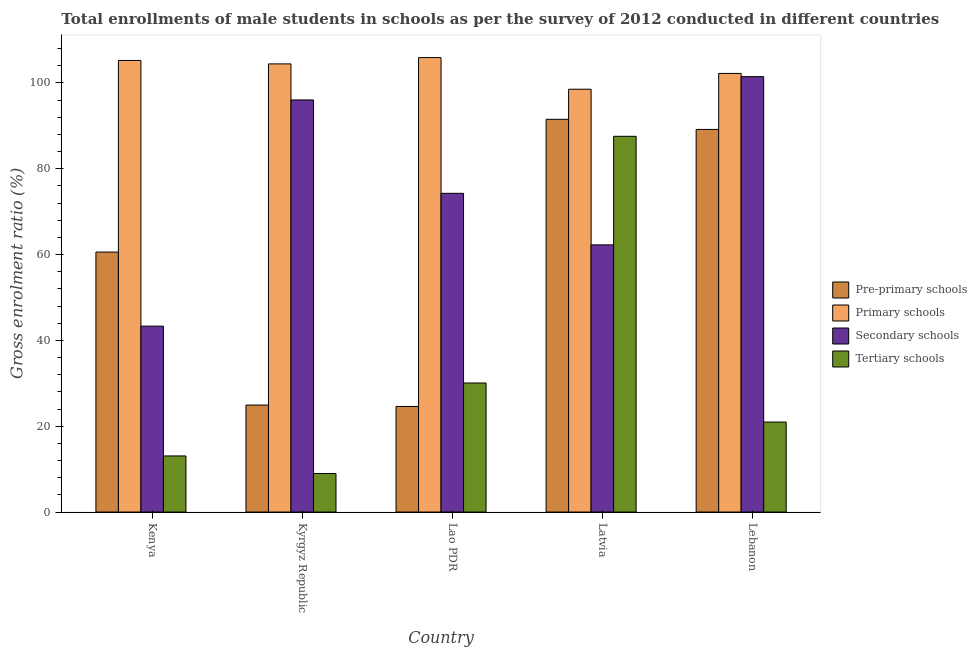How many different coloured bars are there?
Your response must be concise. 4. How many bars are there on the 2nd tick from the left?
Provide a short and direct response. 4. What is the label of the 2nd group of bars from the left?
Your answer should be very brief. Kyrgyz Republic. In how many cases, is the number of bars for a given country not equal to the number of legend labels?
Offer a terse response. 0. What is the gross enrolment ratio(male) in pre-primary schools in Lao PDR?
Keep it short and to the point. 24.6. Across all countries, what is the maximum gross enrolment ratio(male) in primary schools?
Offer a terse response. 105.9. Across all countries, what is the minimum gross enrolment ratio(male) in pre-primary schools?
Make the answer very short. 24.6. In which country was the gross enrolment ratio(male) in pre-primary schools maximum?
Your response must be concise. Latvia. In which country was the gross enrolment ratio(male) in primary schools minimum?
Keep it short and to the point. Latvia. What is the total gross enrolment ratio(male) in secondary schools in the graph?
Keep it short and to the point. 377.36. What is the difference between the gross enrolment ratio(male) in secondary schools in Kyrgyz Republic and that in Lao PDR?
Offer a very short reply. 21.76. What is the difference between the gross enrolment ratio(male) in secondary schools in Kenya and the gross enrolment ratio(male) in primary schools in Kyrgyz Republic?
Provide a succinct answer. -61.11. What is the average gross enrolment ratio(male) in tertiary schools per country?
Keep it short and to the point. 32.13. What is the difference between the gross enrolment ratio(male) in pre-primary schools and gross enrolment ratio(male) in tertiary schools in Kenya?
Make the answer very short. 47.51. What is the ratio of the gross enrolment ratio(male) in pre-primary schools in Kyrgyz Republic to that in Lebanon?
Offer a very short reply. 0.28. Is the difference between the gross enrolment ratio(male) in pre-primary schools in Kenya and Lebanon greater than the difference between the gross enrolment ratio(male) in primary schools in Kenya and Lebanon?
Your answer should be compact. No. What is the difference between the highest and the second highest gross enrolment ratio(male) in secondary schools?
Your response must be concise. 5.43. What is the difference between the highest and the lowest gross enrolment ratio(male) in secondary schools?
Give a very brief answer. 58.14. Is the sum of the gross enrolment ratio(male) in tertiary schools in Lao PDR and Latvia greater than the maximum gross enrolment ratio(male) in pre-primary schools across all countries?
Provide a short and direct response. Yes. Is it the case that in every country, the sum of the gross enrolment ratio(male) in pre-primary schools and gross enrolment ratio(male) in secondary schools is greater than the sum of gross enrolment ratio(male) in tertiary schools and gross enrolment ratio(male) in primary schools?
Your answer should be very brief. No. What does the 4th bar from the left in Lebanon represents?
Provide a succinct answer. Tertiary schools. What does the 2nd bar from the right in Kenya represents?
Offer a terse response. Secondary schools. Is it the case that in every country, the sum of the gross enrolment ratio(male) in pre-primary schools and gross enrolment ratio(male) in primary schools is greater than the gross enrolment ratio(male) in secondary schools?
Offer a very short reply. Yes. How many countries are there in the graph?
Give a very brief answer. 5. What is the difference between two consecutive major ticks on the Y-axis?
Your response must be concise. 20. Are the values on the major ticks of Y-axis written in scientific E-notation?
Your response must be concise. No. Where does the legend appear in the graph?
Give a very brief answer. Center right. How many legend labels are there?
Your answer should be very brief. 4. How are the legend labels stacked?
Offer a very short reply. Vertical. What is the title of the graph?
Give a very brief answer. Total enrollments of male students in schools as per the survey of 2012 conducted in different countries. Does "Secondary vocational education" appear as one of the legend labels in the graph?
Keep it short and to the point. No. What is the label or title of the X-axis?
Your answer should be compact. Country. What is the label or title of the Y-axis?
Your answer should be very brief. Gross enrolment ratio (%). What is the Gross enrolment ratio (%) in Pre-primary schools in Kenya?
Ensure brevity in your answer.  60.58. What is the Gross enrolment ratio (%) of Primary schools in Kenya?
Provide a short and direct response. 105.23. What is the Gross enrolment ratio (%) in Secondary schools in Kenya?
Your response must be concise. 43.32. What is the Gross enrolment ratio (%) in Tertiary schools in Kenya?
Offer a terse response. 13.07. What is the Gross enrolment ratio (%) in Pre-primary schools in Kyrgyz Republic?
Keep it short and to the point. 24.93. What is the Gross enrolment ratio (%) in Primary schools in Kyrgyz Republic?
Your response must be concise. 104.43. What is the Gross enrolment ratio (%) in Secondary schools in Kyrgyz Republic?
Keep it short and to the point. 96.03. What is the Gross enrolment ratio (%) of Tertiary schools in Kyrgyz Republic?
Your response must be concise. 8.98. What is the Gross enrolment ratio (%) in Pre-primary schools in Lao PDR?
Make the answer very short. 24.6. What is the Gross enrolment ratio (%) in Primary schools in Lao PDR?
Your answer should be very brief. 105.9. What is the Gross enrolment ratio (%) in Secondary schools in Lao PDR?
Offer a very short reply. 74.27. What is the Gross enrolment ratio (%) in Tertiary schools in Lao PDR?
Provide a succinct answer. 30.07. What is the Gross enrolment ratio (%) in Pre-primary schools in Latvia?
Offer a terse response. 91.52. What is the Gross enrolment ratio (%) in Primary schools in Latvia?
Give a very brief answer. 98.53. What is the Gross enrolment ratio (%) of Secondary schools in Latvia?
Ensure brevity in your answer.  62.26. What is the Gross enrolment ratio (%) of Tertiary schools in Latvia?
Ensure brevity in your answer.  87.56. What is the Gross enrolment ratio (%) of Pre-primary schools in Lebanon?
Your answer should be very brief. 89.16. What is the Gross enrolment ratio (%) of Primary schools in Lebanon?
Ensure brevity in your answer.  102.21. What is the Gross enrolment ratio (%) in Secondary schools in Lebanon?
Your response must be concise. 101.47. What is the Gross enrolment ratio (%) in Tertiary schools in Lebanon?
Keep it short and to the point. 20.97. Across all countries, what is the maximum Gross enrolment ratio (%) of Pre-primary schools?
Provide a short and direct response. 91.52. Across all countries, what is the maximum Gross enrolment ratio (%) in Primary schools?
Keep it short and to the point. 105.9. Across all countries, what is the maximum Gross enrolment ratio (%) in Secondary schools?
Give a very brief answer. 101.47. Across all countries, what is the maximum Gross enrolment ratio (%) in Tertiary schools?
Your answer should be compact. 87.56. Across all countries, what is the minimum Gross enrolment ratio (%) of Pre-primary schools?
Keep it short and to the point. 24.6. Across all countries, what is the minimum Gross enrolment ratio (%) of Primary schools?
Provide a short and direct response. 98.53. Across all countries, what is the minimum Gross enrolment ratio (%) of Secondary schools?
Give a very brief answer. 43.32. Across all countries, what is the minimum Gross enrolment ratio (%) of Tertiary schools?
Offer a terse response. 8.98. What is the total Gross enrolment ratio (%) of Pre-primary schools in the graph?
Keep it short and to the point. 290.79. What is the total Gross enrolment ratio (%) in Primary schools in the graph?
Your answer should be very brief. 516.31. What is the total Gross enrolment ratio (%) of Secondary schools in the graph?
Provide a short and direct response. 377.36. What is the total Gross enrolment ratio (%) of Tertiary schools in the graph?
Your answer should be very brief. 160.66. What is the difference between the Gross enrolment ratio (%) in Pre-primary schools in Kenya and that in Kyrgyz Republic?
Offer a very short reply. 35.65. What is the difference between the Gross enrolment ratio (%) of Primary schools in Kenya and that in Kyrgyz Republic?
Give a very brief answer. 0.8. What is the difference between the Gross enrolment ratio (%) of Secondary schools in Kenya and that in Kyrgyz Republic?
Provide a succinct answer. -52.71. What is the difference between the Gross enrolment ratio (%) in Tertiary schools in Kenya and that in Kyrgyz Republic?
Your response must be concise. 4.09. What is the difference between the Gross enrolment ratio (%) of Pre-primary schools in Kenya and that in Lao PDR?
Offer a very short reply. 35.98. What is the difference between the Gross enrolment ratio (%) of Primary schools in Kenya and that in Lao PDR?
Provide a short and direct response. -0.67. What is the difference between the Gross enrolment ratio (%) in Secondary schools in Kenya and that in Lao PDR?
Make the answer very short. -30.95. What is the difference between the Gross enrolment ratio (%) of Tertiary schools in Kenya and that in Lao PDR?
Give a very brief answer. -17. What is the difference between the Gross enrolment ratio (%) of Pre-primary schools in Kenya and that in Latvia?
Ensure brevity in your answer.  -30.94. What is the difference between the Gross enrolment ratio (%) of Primary schools in Kenya and that in Latvia?
Your answer should be compact. 6.7. What is the difference between the Gross enrolment ratio (%) of Secondary schools in Kenya and that in Latvia?
Ensure brevity in your answer.  -18.94. What is the difference between the Gross enrolment ratio (%) of Tertiary schools in Kenya and that in Latvia?
Offer a terse response. -74.49. What is the difference between the Gross enrolment ratio (%) of Pre-primary schools in Kenya and that in Lebanon?
Ensure brevity in your answer.  -28.58. What is the difference between the Gross enrolment ratio (%) of Primary schools in Kenya and that in Lebanon?
Offer a very short reply. 3.02. What is the difference between the Gross enrolment ratio (%) of Secondary schools in Kenya and that in Lebanon?
Keep it short and to the point. -58.14. What is the difference between the Gross enrolment ratio (%) in Tertiary schools in Kenya and that in Lebanon?
Ensure brevity in your answer.  -7.9. What is the difference between the Gross enrolment ratio (%) of Pre-primary schools in Kyrgyz Republic and that in Lao PDR?
Give a very brief answer. 0.33. What is the difference between the Gross enrolment ratio (%) of Primary schools in Kyrgyz Republic and that in Lao PDR?
Offer a very short reply. -1.47. What is the difference between the Gross enrolment ratio (%) of Secondary schools in Kyrgyz Republic and that in Lao PDR?
Make the answer very short. 21.76. What is the difference between the Gross enrolment ratio (%) of Tertiary schools in Kyrgyz Republic and that in Lao PDR?
Give a very brief answer. -21.09. What is the difference between the Gross enrolment ratio (%) in Pre-primary schools in Kyrgyz Republic and that in Latvia?
Your response must be concise. -66.59. What is the difference between the Gross enrolment ratio (%) in Primary schools in Kyrgyz Republic and that in Latvia?
Give a very brief answer. 5.9. What is the difference between the Gross enrolment ratio (%) of Secondary schools in Kyrgyz Republic and that in Latvia?
Offer a very short reply. 33.77. What is the difference between the Gross enrolment ratio (%) in Tertiary schools in Kyrgyz Republic and that in Latvia?
Keep it short and to the point. -78.58. What is the difference between the Gross enrolment ratio (%) in Pre-primary schools in Kyrgyz Republic and that in Lebanon?
Give a very brief answer. -64.23. What is the difference between the Gross enrolment ratio (%) of Primary schools in Kyrgyz Republic and that in Lebanon?
Your answer should be compact. 2.22. What is the difference between the Gross enrolment ratio (%) of Secondary schools in Kyrgyz Republic and that in Lebanon?
Offer a very short reply. -5.43. What is the difference between the Gross enrolment ratio (%) in Tertiary schools in Kyrgyz Republic and that in Lebanon?
Offer a terse response. -11.99. What is the difference between the Gross enrolment ratio (%) of Pre-primary schools in Lao PDR and that in Latvia?
Provide a succinct answer. -66.92. What is the difference between the Gross enrolment ratio (%) of Primary schools in Lao PDR and that in Latvia?
Keep it short and to the point. 7.37. What is the difference between the Gross enrolment ratio (%) in Secondary schools in Lao PDR and that in Latvia?
Your response must be concise. 12.01. What is the difference between the Gross enrolment ratio (%) in Tertiary schools in Lao PDR and that in Latvia?
Make the answer very short. -57.49. What is the difference between the Gross enrolment ratio (%) of Pre-primary schools in Lao PDR and that in Lebanon?
Provide a succinct answer. -64.56. What is the difference between the Gross enrolment ratio (%) in Primary schools in Lao PDR and that in Lebanon?
Provide a succinct answer. 3.69. What is the difference between the Gross enrolment ratio (%) in Secondary schools in Lao PDR and that in Lebanon?
Your answer should be compact. -27.19. What is the difference between the Gross enrolment ratio (%) of Tertiary schools in Lao PDR and that in Lebanon?
Keep it short and to the point. 9.1. What is the difference between the Gross enrolment ratio (%) in Pre-primary schools in Latvia and that in Lebanon?
Give a very brief answer. 2.36. What is the difference between the Gross enrolment ratio (%) of Primary schools in Latvia and that in Lebanon?
Offer a very short reply. -3.68. What is the difference between the Gross enrolment ratio (%) in Secondary schools in Latvia and that in Lebanon?
Give a very brief answer. -39.21. What is the difference between the Gross enrolment ratio (%) in Tertiary schools in Latvia and that in Lebanon?
Provide a succinct answer. 66.59. What is the difference between the Gross enrolment ratio (%) in Pre-primary schools in Kenya and the Gross enrolment ratio (%) in Primary schools in Kyrgyz Republic?
Your response must be concise. -43.85. What is the difference between the Gross enrolment ratio (%) of Pre-primary schools in Kenya and the Gross enrolment ratio (%) of Secondary schools in Kyrgyz Republic?
Ensure brevity in your answer.  -35.45. What is the difference between the Gross enrolment ratio (%) of Pre-primary schools in Kenya and the Gross enrolment ratio (%) of Tertiary schools in Kyrgyz Republic?
Your response must be concise. 51.6. What is the difference between the Gross enrolment ratio (%) in Primary schools in Kenya and the Gross enrolment ratio (%) in Secondary schools in Kyrgyz Republic?
Offer a very short reply. 9.2. What is the difference between the Gross enrolment ratio (%) of Primary schools in Kenya and the Gross enrolment ratio (%) of Tertiary schools in Kyrgyz Republic?
Give a very brief answer. 96.25. What is the difference between the Gross enrolment ratio (%) of Secondary schools in Kenya and the Gross enrolment ratio (%) of Tertiary schools in Kyrgyz Republic?
Your answer should be very brief. 34.34. What is the difference between the Gross enrolment ratio (%) in Pre-primary schools in Kenya and the Gross enrolment ratio (%) in Primary schools in Lao PDR?
Give a very brief answer. -45.32. What is the difference between the Gross enrolment ratio (%) in Pre-primary schools in Kenya and the Gross enrolment ratio (%) in Secondary schools in Lao PDR?
Keep it short and to the point. -13.69. What is the difference between the Gross enrolment ratio (%) in Pre-primary schools in Kenya and the Gross enrolment ratio (%) in Tertiary schools in Lao PDR?
Keep it short and to the point. 30.51. What is the difference between the Gross enrolment ratio (%) of Primary schools in Kenya and the Gross enrolment ratio (%) of Secondary schools in Lao PDR?
Offer a terse response. 30.96. What is the difference between the Gross enrolment ratio (%) of Primary schools in Kenya and the Gross enrolment ratio (%) of Tertiary schools in Lao PDR?
Your answer should be compact. 75.16. What is the difference between the Gross enrolment ratio (%) of Secondary schools in Kenya and the Gross enrolment ratio (%) of Tertiary schools in Lao PDR?
Offer a very short reply. 13.25. What is the difference between the Gross enrolment ratio (%) of Pre-primary schools in Kenya and the Gross enrolment ratio (%) of Primary schools in Latvia?
Offer a terse response. -37.95. What is the difference between the Gross enrolment ratio (%) of Pre-primary schools in Kenya and the Gross enrolment ratio (%) of Secondary schools in Latvia?
Keep it short and to the point. -1.68. What is the difference between the Gross enrolment ratio (%) in Pre-primary schools in Kenya and the Gross enrolment ratio (%) in Tertiary schools in Latvia?
Your answer should be compact. -26.98. What is the difference between the Gross enrolment ratio (%) in Primary schools in Kenya and the Gross enrolment ratio (%) in Secondary schools in Latvia?
Offer a very short reply. 42.97. What is the difference between the Gross enrolment ratio (%) of Primary schools in Kenya and the Gross enrolment ratio (%) of Tertiary schools in Latvia?
Your answer should be compact. 17.67. What is the difference between the Gross enrolment ratio (%) in Secondary schools in Kenya and the Gross enrolment ratio (%) in Tertiary schools in Latvia?
Provide a succinct answer. -44.24. What is the difference between the Gross enrolment ratio (%) in Pre-primary schools in Kenya and the Gross enrolment ratio (%) in Primary schools in Lebanon?
Your answer should be very brief. -41.63. What is the difference between the Gross enrolment ratio (%) in Pre-primary schools in Kenya and the Gross enrolment ratio (%) in Secondary schools in Lebanon?
Provide a short and direct response. -40.89. What is the difference between the Gross enrolment ratio (%) of Pre-primary schools in Kenya and the Gross enrolment ratio (%) of Tertiary schools in Lebanon?
Provide a succinct answer. 39.61. What is the difference between the Gross enrolment ratio (%) of Primary schools in Kenya and the Gross enrolment ratio (%) of Secondary schools in Lebanon?
Ensure brevity in your answer.  3.77. What is the difference between the Gross enrolment ratio (%) of Primary schools in Kenya and the Gross enrolment ratio (%) of Tertiary schools in Lebanon?
Give a very brief answer. 84.26. What is the difference between the Gross enrolment ratio (%) of Secondary schools in Kenya and the Gross enrolment ratio (%) of Tertiary schools in Lebanon?
Offer a very short reply. 22.35. What is the difference between the Gross enrolment ratio (%) in Pre-primary schools in Kyrgyz Republic and the Gross enrolment ratio (%) in Primary schools in Lao PDR?
Your answer should be very brief. -80.97. What is the difference between the Gross enrolment ratio (%) in Pre-primary schools in Kyrgyz Republic and the Gross enrolment ratio (%) in Secondary schools in Lao PDR?
Give a very brief answer. -49.34. What is the difference between the Gross enrolment ratio (%) in Pre-primary schools in Kyrgyz Republic and the Gross enrolment ratio (%) in Tertiary schools in Lao PDR?
Keep it short and to the point. -5.14. What is the difference between the Gross enrolment ratio (%) of Primary schools in Kyrgyz Republic and the Gross enrolment ratio (%) of Secondary schools in Lao PDR?
Offer a very short reply. 30.16. What is the difference between the Gross enrolment ratio (%) of Primary schools in Kyrgyz Republic and the Gross enrolment ratio (%) of Tertiary schools in Lao PDR?
Offer a terse response. 74.36. What is the difference between the Gross enrolment ratio (%) in Secondary schools in Kyrgyz Republic and the Gross enrolment ratio (%) in Tertiary schools in Lao PDR?
Your response must be concise. 65.96. What is the difference between the Gross enrolment ratio (%) in Pre-primary schools in Kyrgyz Republic and the Gross enrolment ratio (%) in Primary schools in Latvia?
Give a very brief answer. -73.6. What is the difference between the Gross enrolment ratio (%) of Pre-primary schools in Kyrgyz Republic and the Gross enrolment ratio (%) of Secondary schools in Latvia?
Make the answer very short. -37.33. What is the difference between the Gross enrolment ratio (%) in Pre-primary schools in Kyrgyz Republic and the Gross enrolment ratio (%) in Tertiary schools in Latvia?
Provide a short and direct response. -62.63. What is the difference between the Gross enrolment ratio (%) in Primary schools in Kyrgyz Republic and the Gross enrolment ratio (%) in Secondary schools in Latvia?
Ensure brevity in your answer.  42.17. What is the difference between the Gross enrolment ratio (%) of Primary schools in Kyrgyz Republic and the Gross enrolment ratio (%) of Tertiary schools in Latvia?
Keep it short and to the point. 16.87. What is the difference between the Gross enrolment ratio (%) in Secondary schools in Kyrgyz Republic and the Gross enrolment ratio (%) in Tertiary schools in Latvia?
Provide a short and direct response. 8.47. What is the difference between the Gross enrolment ratio (%) in Pre-primary schools in Kyrgyz Republic and the Gross enrolment ratio (%) in Primary schools in Lebanon?
Your answer should be very brief. -77.28. What is the difference between the Gross enrolment ratio (%) of Pre-primary schools in Kyrgyz Republic and the Gross enrolment ratio (%) of Secondary schools in Lebanon?
Keep it short and to the point. -76.53. What is the difference between the Gross enrolment ratio (%) of Pre-primary schools in Kyrgyz Republic and the Gross enrolment ratio (%) of Tertiary schools in Lebanon?
Provide a short and direct response. 3.96. What is the difference between the Gross enrolment ratio (%) of Primary schools in Kyrgyz Republic and the Gross enrolment ratio (%) of Secondary schools in Lebanon?
Make the answer very short. 2.97. What is the difference between the Gross enrolment ratio (%) of Primary schools in Kyrgyz Republic and the Gross enrolment ratio (%) of Tertiary schools in Lebanon?
Provide a succinct answer. 83.46. What is the difference between the Gross enrolment ratio (%) in Secondary schools in Kyrgyz Republic and the Gross enrolment ratio (%) in Tertiary schools in Lebanon?
Make the answer very short. 75.06. What is the difference between the Gross enrolment ratio (%) in Pre-primary schools in Lao PDR and the Gross enrolment ratio (%) in Primary schools in Latvia?
Ensure brevity in your answer.  -73.93. What is the difference between the Gross enrolment ratio (%) of Pre-primary schools in Lao PDR and the Gross enrolment ratio (%) of Secondary schools in Latvia?
Keep it short and to the point. -37.66. What is the difference between the Gross enrolment ratio (%) in Pre-primary schools in Lao PDR and the Gross enrolment ratio (%) in Tertiary schools in Latvia?
Your response must be concise. -62.96. What is the difference between the Gross enrolment ratio (%) of Primary schools in Lao PDR and the Gross enrolment ratio (%) of Secondary schools in Latvia?
Provide a short and direct response. 43.64. What is the difference between the Gross enrolment ratio (%) in Primary schools in Lao PDR and the Gross enrolment ratio (%) in Tertiary schools in Latvia?
Your answer should be compact. 18.34. What is the difference between the Gross enrolment ratio (%) in Secondary schools in Lao PDR and the Gross enrolment ratio (%) in Tertiary schools in Latvia?
Your answer should be very brief. -13.29. What is the difference between the Gross enrolment ratio (%) of Pre-primary schools in Lao PDR and the Gross enrolment ratio (%) of Primary schools in Lebanon?
Make the answer very short. -77.61. What is the difference between the Gross enrolment ratio (%) in Pre-primary schools in Lao PDR and the Gross enrolment ratio (%) in Secondary schools in Lebanon?
Your answer should be compact. -76.86. What is the difference between the Gross enrolment ratio (%) in Pre-primary schools in Lao PDR and the Gross enrolment ratio (%) in Tertiary schools in Lebanon?
Make the answer very short. 3.63. What is the difference between the Gross enrolment ratio (%) in Primary schools in Lao PDR and the Gross enrolment ratio (%) in Secondary schools in Lebanon?
Your answer should be very brief. 4.44. What is the difference between the Gross enrolment ratio (%) of Primary schools in Lao PDR and the Gross enrolment ratio (%) of Tertiary schools in Lebanon?
Make the answer very short. 84.93. What is the difference between the Gross enrolment ratio (%) in Secondary schools in Lao PDR and the Gross enrolment ratio (%) in Tertiary schools in Lebanon?
Provide a succinct answer. 53.3. What is the difference between the Gross enrolment ratio (%) in Pre-primary schools in Latvia and the Gross enrolment ratio (%) in Primary schools in Lebanon?
Provide a short and direct response. -10.69. What is the difference between the Gross enrolment ratio (%) in Pre-primary schools in Latvia and the Gross enrolment ratio (%) in Secondary schools in Lebanon?
Give a very brief answer. -9.95. What is the difference between the Gross enrolment ratio (%) in Pre-primary schools in Latvia and the Gross enrolment ratio (%) in Tertiary schools in Lebanon?
Ensure brevity in your answer.  70.55. What is the difference between the Gross enrolment ratio (%) in Primary schools in Latvia and the Gross enrolment ratio (%) in Secondary schools in Lebanon?
Provide a succinct answer. -2.94. What is the difference between the Gross enrolment ratio (%) in Primary schools in Latvia and the Gross enrolment ratio (%) in Tertiary schools in Lebanon?
Your response must be concise. 77.56. What is the difference between the Gross enrolment ratio (%) of Secondary schools in Latvia and the Gross enrolment ratio (%) of Tertiary schools in Lebanon?
Make the answer very short. 41.29. What is the average Gross enrolment ratio (%) of Pre-primary schools per country?
Your answer should be compact. 58.16. What is the average Gross enrolment ratio (%) in Primary schools per country?
Provide a short and direct response. 103.26. What is the average Gross enrolment ratio (%) in Secondary schools per country?
Offer a very short reply. 75.47. What is the average Gross enrolment ratio (%) of Tertiary schools per country?
Provide a succinct answer. 32.13. What is the difference between the Gross enrolment ratio (%) in Pre-primary schools and Gross enrolment ratio (%) in Primary schools in Kenya?
Your answer should be very brief. -44.65. What is the difference between the Gross enrolment ratio (%) in Pre-primary schools and Gross enrolment ratio (%) in Secondary schools in Kenya?
Offer a very short reply. 17.26. What is the difference between the Gross enrolment ratio (%) in Pre-primary schools and Gross enrolment ratio (%) in Tertiary schools in Kenya?
Your response must be concise. 47.51. What is the difference between the Gross enrolment ratio (%) of Primary schools and Gross enrolment ratio (%) of Secondary schools in Kenya?
Offer a terse response. 61.91. What is the difference between the Gross enrolment ratio (%) of Primary schools and Gross enrolment ratio (%) of Tertiary schools in Kenya?
Make the answer very short. 92.16. What is the difference between the Gross enrolment ratio (%) in Secondary schools and Gross enrolment ratio (%) in Tertiary schools in Kenya?
Your response must be concise. 30.25. What is the difference between the Gross enrolment ratio (%) of Pre-primary schools and Gross enrolment ratio (%) of Primary schools in Kyrgyz Republic?
Provide a short and direct response. -79.5. What is the difference between the Gross enrolment ratio (%) in Pre-primary schools and Gross enrolment ratio (%) in Secondary schools in Kyrgyz Republic?
Make the answer very short. -71.1. What is the difference between the Gross enrolment ratio (%) in Pre-primary schools and Gross enrolment ratio (%) in Tertiary schools in Kyrgyz Republic?
Ensure brevity in your answer.  15.95. What is the difference between the Gross enrolment ratio (%) of Primary schools and Gross enrolment ratio (%) of Secondary schools in Kyrgyz Republic?
Provide a short and direct response. 8.4. What is the difference between the Gross enrolment ratio (%) in Primary schools and Gross enrolment ratio (%) in Tertiary schools in Kyrgyz Republic?
Your answer should be very brief. 95.45. What is the difference between the Gross enrolment ratio (%) of Secondary schools and Gross enrolment ratio (%) of Tertiary schools in Kyrgyz Republic?
Provide a succinct answer. 87.05. What is the difference between the Gross enrolment ratio (%) in Pre-primary schools and Gross enrolment ratio (%) in Primary schools in Lao PDR?
Give a very brief answer. -81.3. What is the difference between the Gross enrolment ratio (%) of Pre-primary schools and Gross enrolment ratio (%) of Secondary schools in Lao PDR?
Provide a short and direct response. -49.67. What is the difference between the Gross enrolment ratio (%) of Pre-primary schools and Gross enrolment ratio (%) of Tertiary schools in Lao PDR?
Give a very brief answer. -5.47. What is the difference between the Gross enrolment ratio (%) in Primary schools and Gross enrolment ratio (%) in Secondary schools in Lao PDR?
Your response must be concise. 31.63. What is the difference between the Gross enrolment ratio (%) in Primary schools and Gross enrolment ratio (%) in Tertiary schools in Lao PDR?
Ensure brevity in your answer.  75.83. What is the difference between the Gross enrolment ratio (%) in Secondary schools and Gross enrolment ratio (%) in Tertiary schools in Lao PDR?
Provide a short and direct response. 44.2. What is the difference between the Gross enrolment ratio (%) of Pre-primary schools and Gross enrolment ratio (%) of Primary schools in Latvia?
Ensure brevity in your answer.  -7.01. What is the difference between the Gross enrolment ratio (%) in Pre-primary schools and Gross enrolment ratio (%) in Secondary schools in Latvia?
Give a very brief answer. 29.26. What is the difference between the Gross enrolment ratio (%) of Pre-primary schools and Gross enrolment ratio (%) of Tertiary schools in Latvia?
Keep it short and to the point. 3.96. What is the difference between the Gross enrolment ratio (%) of Primary schools and Gross enrolment ratio (%) of Secondary schools in Latvia?
Provide a short and direct response. 36.27. What is the difference between the Gross enrolment ratio (%) in Primary schools and Gross enrolment ratio (%) in Tertiary schools in Latvia?
Ensure brevity in your answer.  10.97. What is the difference between the Gross enrolment ratio (%) in Secondary schools and Gross enrolment ratio (%) in Tertiary schools in Latvia?
Provide a short and direct response. -25.3. What is the difference between the Gross enrolment ratio (%) in Pre-primary schools and Gross enrolment ratio (%) in Primary schools in Lebanon?
Your answer should be compact. -13.05. What is the difference between the Gross enrolment ratio (%) in Pre-primary schools and Gross enrolment ratio (%) in Secondary schools in Lebanon?
Offer a very short reply. -12.31. What is the difference between the Gross enrolment ratio (%) of Pre-primary schools and Gross enrolment ratio (%) of Tertiary schools in Lebanon?
Your response must be concise. 68.19. What is the difference between the Gross enrolment ratio (%) of Primary schools and Gross enrolment ratio (%) of Secondary schools in Lebanon?
Offer a very short reply. 0.75. What is the difference between the Gross enrolment ratio (%) in Primary schools and Gross enrolment ratio (%) in Tertiary schools in Lebanon?
Give a very brief answer. 81.24. What is the difference between the Gross enrolment ratio (%) of Secondary schools and Gross enrolment ratio (%) of Tertiary schools in Lebanon?
Your answer should be very brief. 80.49. What is the ratio of the Gross enrolment ratio (%) of Pre-primary schools in Kenya to that in Kyrgyz Republic?
Your answer should be compact. 2.43. What is the ratio of the Gross enrolment ratio (%) of Primary schools in Kenya to that in Kyrgyz Republic?
Give a very brief answer. 1.01. What is the ratio of the Gross enrolment ratio (%) of Secondary schools in Kenya to that in Kyrgyz Republic?
Offer a terse response. 0.45. What is the ratio of the Gross enrolment ratio (%) in Tertiary schools in Kenya to that in Kyrgyz Republic?
Offer a terse response. 1.46. What is the ratio of the Gross enrolment ratio (%) in Pre-primary schools in Kenya to that in Lao PDR?
Offer a terse response. 2.46. What is the ratio of the Gross enrolment ratio (%) in Secondary schools in Kenya to that in Lao PDR?
Make the answer very short. 0.58. What is the ratio of the Gross enrolment ratio (%) of Tertiary schools in Kenya to that in Lao PDR?
Your response must be concise. 0.43. What is the ratio of the Gross enrolment ratio (%) in Pre-primary schools in Kenya to that in Latvia?
Keep it short and to the point. 0.66. What is the ratio of the Gross enrolment ratio (%) of Primary schools in Kenya to that in Latvia?
Keep it short and to the point. 1.07. What is the ratio of the Gross enrolment ratio (%) in Secondary schools in Kenya to that in Latvia?
Offer a very short reply. 0.7. What is the ratio of the Gross enrolment ratio (%) of Tertiary schools in Kenya to that in Latvia?
Offer a very short reply. 0.15. What is the ratio of the Gross enrolment ratio (%) in Pre-primary schools in Kenya to that in Lebanon?
Offer a terse response. 0.68. What is the ratio of the Gross enrolment ratio (%) in Primary schools in Kenya to that in Lebanon?
Give a very brief answer. 1.03. What is the ratio of the Gross enrolment ratio (%) in Secondary schools in Kenya to that in Lebanon?
Offer a very short reply. 0.43. What is the ratio of the Gross enrolment ratio (%) of Tertiary schools in Kenya to that in Lebanon?
Keep it short and to the point. 0.62. What is the ratio of the Gross enrolment ratio (%) of Pre-primary schools in Kyrgyz Republic to that in Lao PDR?
Ensure brevity in your answer.  1.01. What is the ratio of the Gross enrolment ratio (%) in Primary schools in Kyrgyz Republic to that in Lao PDR?
Ensure brevity in your answer.  0.99. What is the ratio of the Gross enrolment ratio (%) in Secondary schools in Kyrgyz Republic to that in Lao PDR?
Your response must be concise. 1.29. What is the ratio of the Gross enrolment ratio (%) of Tertiary schools in Kyrgyz Republic to that in Lao PDR?
Make the answer very short. 0.3. What is the ratio of the Gross enrolment ratio (%) of Pre-primary schools in Kyrgyz Republic to that in Latvia?
Make the answer very short. 0.27. What is the ratio of the Gross enrolment ratio (%) in Primary schools in Kyrgyz Republic to that in Latvia?
Offer a terse response. 1.06. What is the ratio of the Gross enrolment ratio (%) of Secondary schools in Kyrgyz Republic to that in Latvia?
Offer a very short reply. 1.54. What is the ratio of the Gross enrolment ratio (%) in Tertiary schools in Kyrgyz Republic to that in Latvia?
Keep it short and to the point. 0.1. What is the ratio of the Gross enrolment ratio (%) of Pre-primary schools in Kyrgyz Republic to that in Lebanon?
Your response must be concise. 0.28. What is the ratio of the Gross enrolment ratio (%) of Primary schools in Kyrgyz Republic to that in Lebanon?
Offer a terse response. 1.02. What is the ratio of the Gross enrolment ratio (%) in Secondary schools in Kyrgyz Republic to that in Lebanon?
Provide a succinct answer. 0.95. What is the ratio of the Gross enrolment ratio (%) in Tertiary schools in Kyrgyz Republic to that in Lebanon?
Your answer should be very brief. 0.43. What is the ratio of the Gross enrolment ratio (%) in Pre-primary schools in Lao PDR to that in Latvia?
Your answer should be very brief. 0.27. What is the ratio of the Gross enrolment ratio (%) in Primary schools in Lao PDR to that in Latvia?
Give a very brief answer. 1.07. What is the ratio of the Gross enrolment ratio (%) in Secondary schools in Lao PDR to that in Latvia?
Offer a terse response. 1.19. What is the ratio of the Gross enrolment ratio (%) in Tertiary schools in Lao PDR to that in Latvia?
Provide a succinct answer. 0.34. What is the ratio of the Gross enrolment ratio (%) in Pre-primary schools in Lao PDR to that in Lebanon?
Give a very brief answer. 0.28. What is the ratio of the Gross enrolment ratio (%) in Primary schools in Lao PDR to that in Lebanon?
Offer a very short reply. 1.04. What is the ratio of the Gross enrolment ratio (%) in Secondary schools in Lao PDR to that in Lebanon?
Keep it short and to the point. 0.73. What is the ratio of the Gross enrolment ratio (%) of Tertiary schools in Lao PDR to that in Lebanon?
Provide a short and direct response. 1.43. What is the ratio of the Gross enrolment ratio (%) in Pre-primary schools in Latvia to that in Lebanon?
Provide a succinct answer. 1.03. What is the ratio of the Gross enrolment ratio (%) in Secondary schools in Latvia to that in Lebanon?
Your answer should be very brief. 0.61. What is the ratio of the Gross enrolment ratio (%) of Tertiary schools in Latvia to that in Lebanon?
Your answer should be compact. 4.18. What is the difference between the highest and the second highest Gross enrolment ratio (%) in Pre-primary schools?
Your answer should be very brief. 2.36. What is the difference between the highest and the second highest Gross enrolment ratio (%) in Primary schools?
Your answer should be very brief. 0.67. What is the difference between the highest and the second highest Gross enrolment ratio (%) of Secondary schools?
Provide a succinct answer. 5.43. What is the difference between the highest and the second highest Gross enrolment ratio (%) of Tertiary schools?
Give a very brief answer. 57.49. What is the difference between the highest and the lowest Gross enrolment ratio (%) of Pre-primary schools?
Provide a succinct answer. 66.92. What is the difference between the highest and the lowest Gross enrolment ratio (%) in Primary schools?
Your answer should be compact. 7.37. What is the difference between the highest and the lowest Gross enrolment ratio (%) of Secondary schools?
Ensure brevity in your answer.  58.14. What is the difference between the highest and the lowest Gross enrolment ratio (%) in Tertiary schools?
Keep it short and to the point. 78.58. 